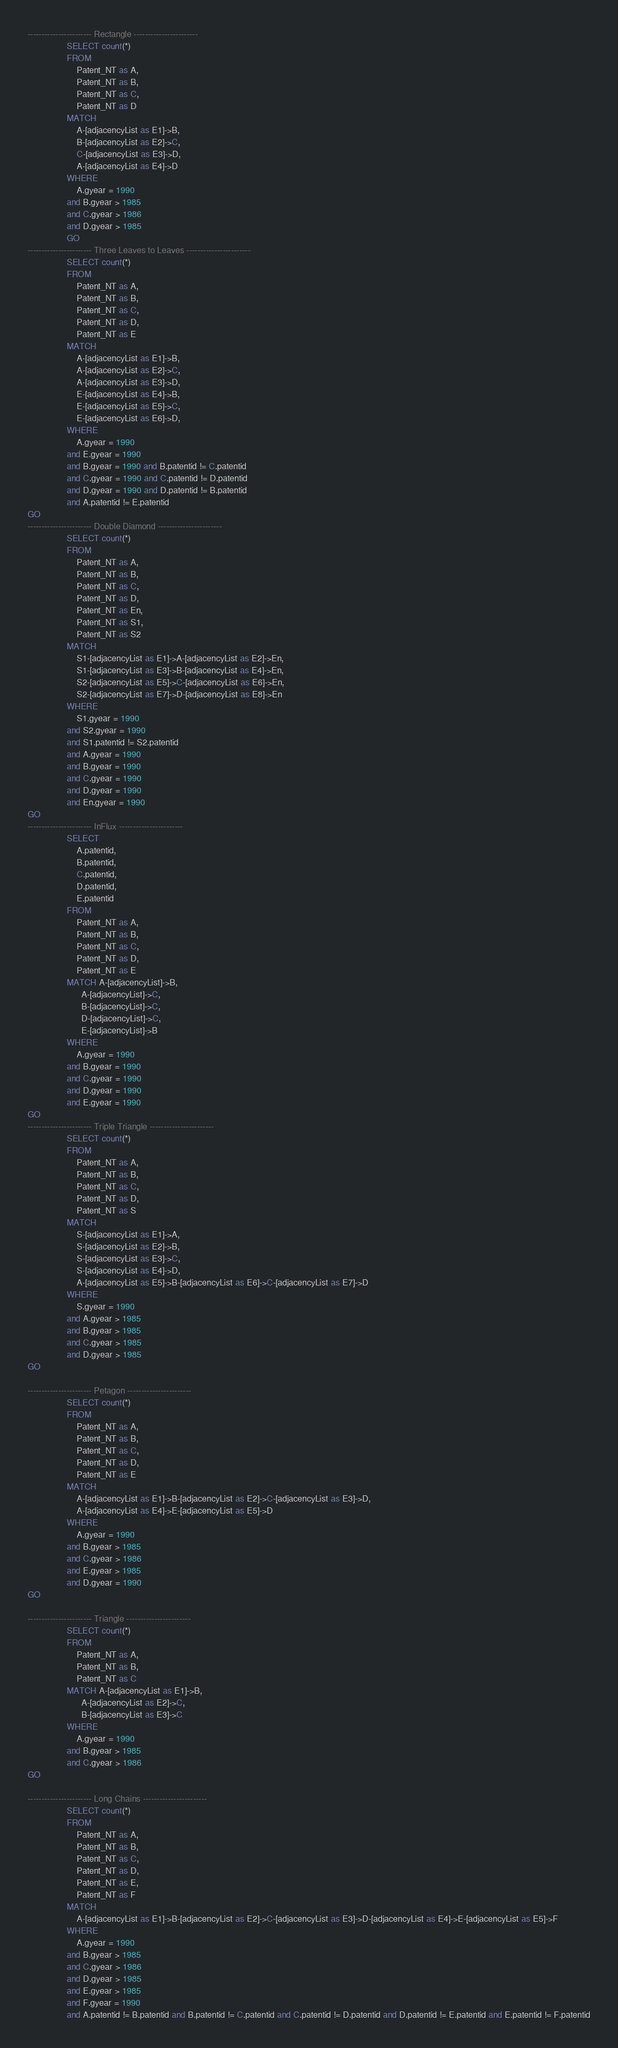<code> <loc_0><loc_0><loc_500><loc_500><_SQL_>----------------------- Rectangle -----------------------
				SELECT count(*)
                FROM 
                    Patent_NT as A, 
                    Patent_NT as B, 
                    Patent_NT as C, 
                    Patent_NT as D
                MATCH 
                    A-[adjacencyList as E1]->B,
                    B-[adjacencyList as E2]->C,
                    C-[adjacencyList as E3]->D,
                    A-[adjacencyList as E4]->D
                WHERE
	                A.gyear = 1990
                and B.gyear > 1985
                and C.gyear > 1986
                and D.gyear > 1985 
                GO
----------------------- Three Leaves to Leaves -----------------------
				SELECT count(*)
                FROM 
                    Patent_NT as A, 
                    Patent_NT as B, 
                    Patent_NT as C, 
                    Patent_NT as D,
                    Patent_NT as E
                MATCH 
                    A-[adjacencyList as E1]->B,
                    A-[adjacencyList as E2]->C,
                    A-[adjacencyList as E3]->D,
                    E-[adjacencyList as E4]->B,
                    E-[adjacencyList as E5]->C,
                    E-[adjacencyList as E6]->D,                    
                WHERE
	                A.gyear = 1990
	            and E.gyear = 1990
                and B.gyear = 1990 and B.patentid != C.patentid
                and C.gyear = 1990 and C.patentid != D.patentid
                and D.gyear = 1990 and D.patentid != B.patentid
                and A.patentid != E.patentid
GO
----------------------- Double Diamond -----------------------
                SELECT count(*)
                FROM 
                    Patent_NT as A, 
                    Patent_NT as B, 
                    Patent_NT as C, 
                    Patent_NT as D,
                    Patent_NT as En,
                    Patent_NT as S1,
                    Patent_NT as S2
                MATCH 
                    S1-[adjacencyList as E1]->A-[adjacencyList as E2]->En,
                    S1-[adjacencyList as E3]->B-[adjacencyList as E4]->En,
                    S2-[adjacencyList as E5]->C-[adjacencyList as E6]->En,
                    S2-[adjacencyList as E7]->D-[adjacencyList as E8]->En                   
                WHERE
	                S1.gyear = 1990
	            and S2.gyear = 1990
                and S1.patentid != S2.patentid
                and A.gyear = 1990
                and B.gyear = 1990
                and C.gyear = 1990
                and D.gyear = 1990
                and En.gyear = 1990
GO
----------------------- InFlux -----------------------
                SELECT 
					A.patentid, 
					B.patentid, 
					C.patentid, 
					D.patentid, 
					E.patentid
                FROM 
					Patent_NT as A, 
					Patent_NT as B, 
					Patent_NT as C, 
					Patent_NT as D, 
					Patent_NT as E
                MATCH A-[adjacencyList]->B,
                      A-[adjacencyList]->C,
                      B-[adjacencyList]->C,
                      D-[adjacencyList]->C,          
                      E-[adjacencyList]->B
                WHERE
                    A.gyear = 1990
                and B.gyear = 1990
                and C.gyear = 1990
                and D.gyear = 1990
                and E.gyear = 1990
GO
----------------------- Triple Triangle -----------------------
                SELECT count(*)
                FROM 
                    Patent_NT as A, 
                    Patent_NT as B, 
                    Patent_NT as C, 
                    Patent_NT as D,
                    Patent_NT as S
                MATCH 
                    S-[adjacencyList as E1]->A,
                    S-[adjacencyList as E2]->B,
                    S-[adjacencyList as E3]->C,
                    S-[adjacencyList as E4]->D,
                    A-[adjacencyList as E5]->B-[adjacencyList as E6]->C-[adjacencyList as E7]->D         
                WHERE
	                S.gyear = 1990
                and A.gyear > 1985
                and B.gyear > 1985
                and C.gyear > 1985
                and D.gyear > 1985
GO

----------------------- Petagon -----------------------
	            SELECT count(*)
                FROM 
                    Patent_NT as A, 
                    Patent_NT as B, 
                    Patent_NT as C, 
                    Patent_NT as D,
                    Patent_NT as E
                MATCH 
                    A-[adjacencyList as E1]->B-[adjacencyList as E2]->C-[adjacencyList as E3]->D,
                    A-[adjacencyList as E4]->E-[adjacencyList as E5]->D
                WHERE
	                A.gyear = 1990
                and B.gyear > 1985
                and C.gyear > 1986
                and E.gyear > 1985
                and D.gyear = 1990
GO

----------------------- Triangle -----------------------
	            SELECT count(*)
                FROM 
					Patent_NT as A, 
					Patent_NT as B, 
					Patent_NT as C
                MATCH A-[adjacencyList as E1]->B,
                      A-[adjacencyList as E2]->C,
                      B-[adjacencyList as E3]->C
                WHERE
	                A.gyear = 1990
                and B.gyear > 1985
                and C.gyear > 1986
GO

----------------------- Long Chains -----------------------
	            SELECT count(*)
                FROM 
                    Patent_NT as A, 
                    Patent_NT as B, 
                    Patent_NT as C, 
                    Patent_NT as D,
                    Patent_NT as E,
                    Patent_NT as F
                MATCH 
                    A-[adjacencyList as E1]->B-[adjacencyList as E2]->C-[adjacencyList as E3]->D-[adjacencyList as E4]->E-[adjacencyList as E5]->F
                WHERE
	                A.gyear = 1990
                and B.gyear > 1985
                and C.gyear > 1986
                and D.gyear > 1985
                and E.gyear > 1985
                and F.gyear = 1990
                and A.patentid != B.patentid and B.patentid != C.patentid and C.patentid != D.patentid and D.patentid != E.patentid and E.patentid != F.patentid
</code> 